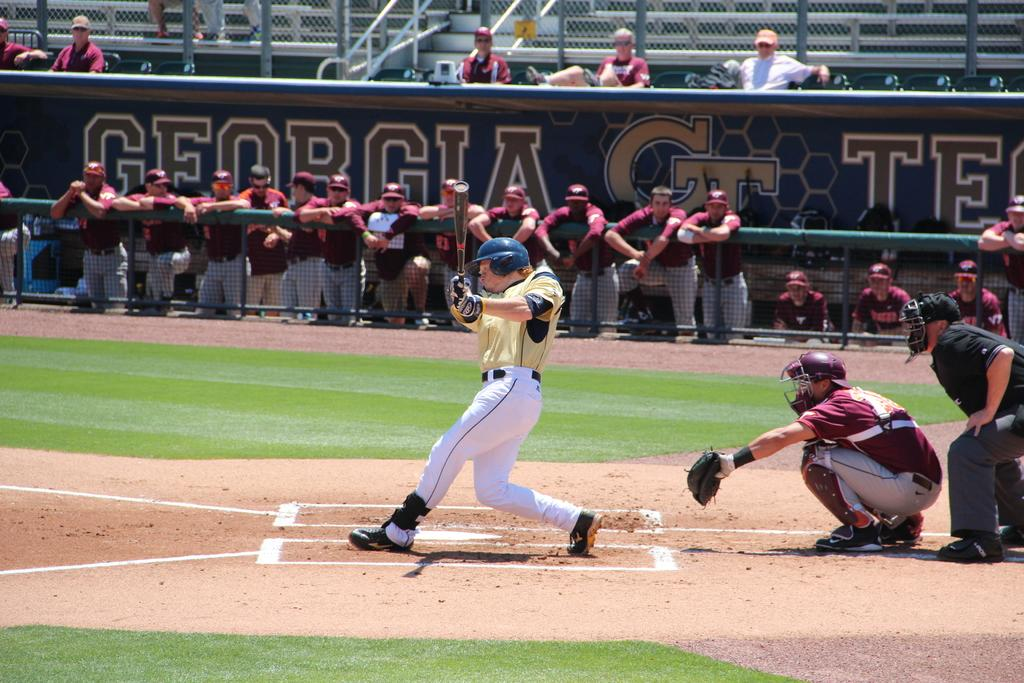<image>
Summarize the visual content of the image. the word Georgia that is on the dugout wall 